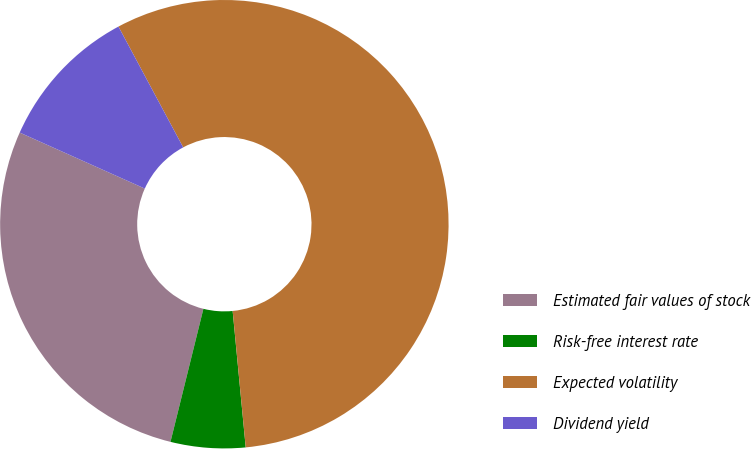Convert chart to OTSL. <chart><loc_0><loc_0><loc_500><loc_500><pie_chart><fcel>Estimated fair values of stock<fcel>Risk-free interest rate<fcel>Expected volatility<fcel>Dividend yield<nl><fcel>27.84%<fcel>5.38%<fcel>56.31%<fcel>10.47%<nl></chart> 